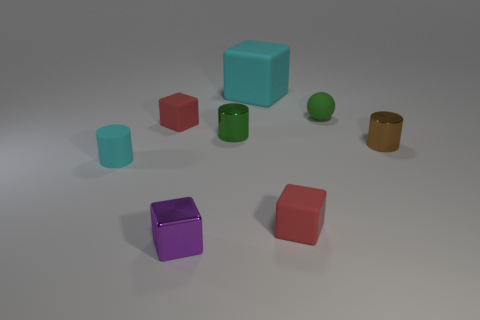There is a tiny green thing that is the same material as the big cyan object; what is its shape?
Make the answer very short. Sphere. There is a tiny rubber cube that is in front of the cyan object that is in front of the tiny brown metal cylinder; what color is it?
Keep it short and to the point. Red. Do the tiny rubber cylinder and the metal block have the same color?
Offer a very short reply. No. The block in front of the red object that is right of the tiny purple metal thing is made of what material?
Your answer should be compact. Metal. What material is the small brown object that is the same shape as the green shiny object?
Give a very brief answer. Metal. Is there a small brown metal object right of the tiny red thing in front of the cylinder behind the brown cylinder?
Give a very brief answer. Yes. What number of other things are there of the same color as the tiny rubber cylinder?
Provide a short and direct response. 1. How many tiny matte objects are on the left side of the big thing and behind the small matte cylinder?
Your answer should be compact. 1. The tiny brown metal thing is what shape?
Your answer should be very brief. Cylinder. How many other objects are the same material as the large object?
Your answer should be compact. 4. 